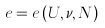<formula> <loc_0><loc_0><loc_500><loc_500>e = e \left ( U , \nu , N \right )</formula> 